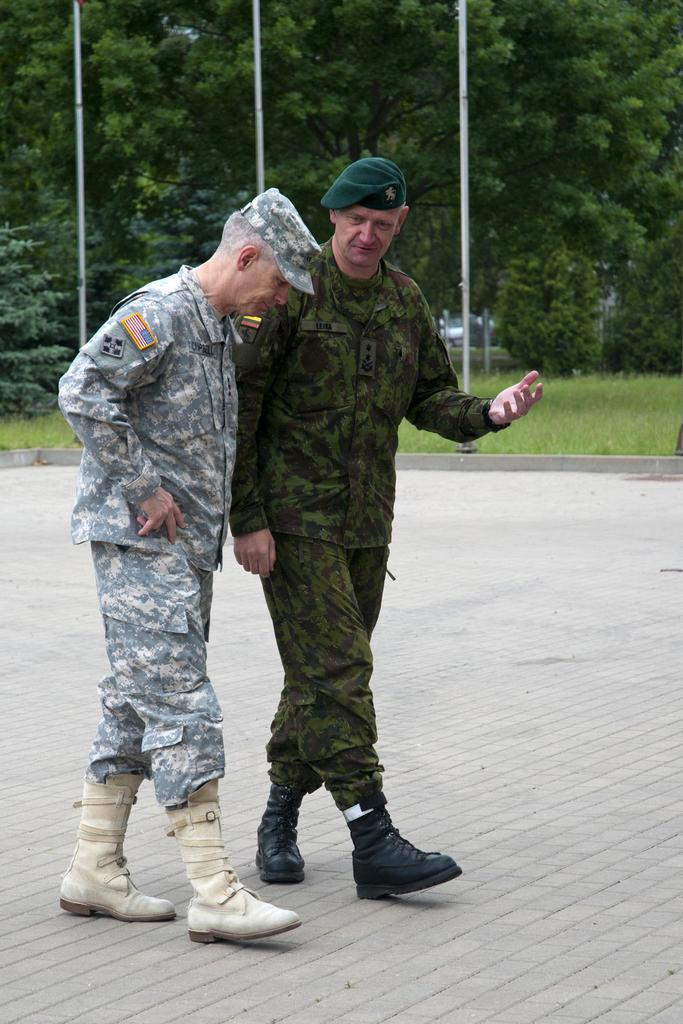How many people are in the image? There are two persons in the image. What are the persons doing in the image? The persons are walking on the floor. What can be seen in the background of the image? There are poles, grass, trees, and plants in the image. What type of lettuce can be seen growing near the trees in the image? There is no lettuce present in the image; it only features trees and other plants. Can you tell me how many horses are visible in the image? There are no horses present in the image. 